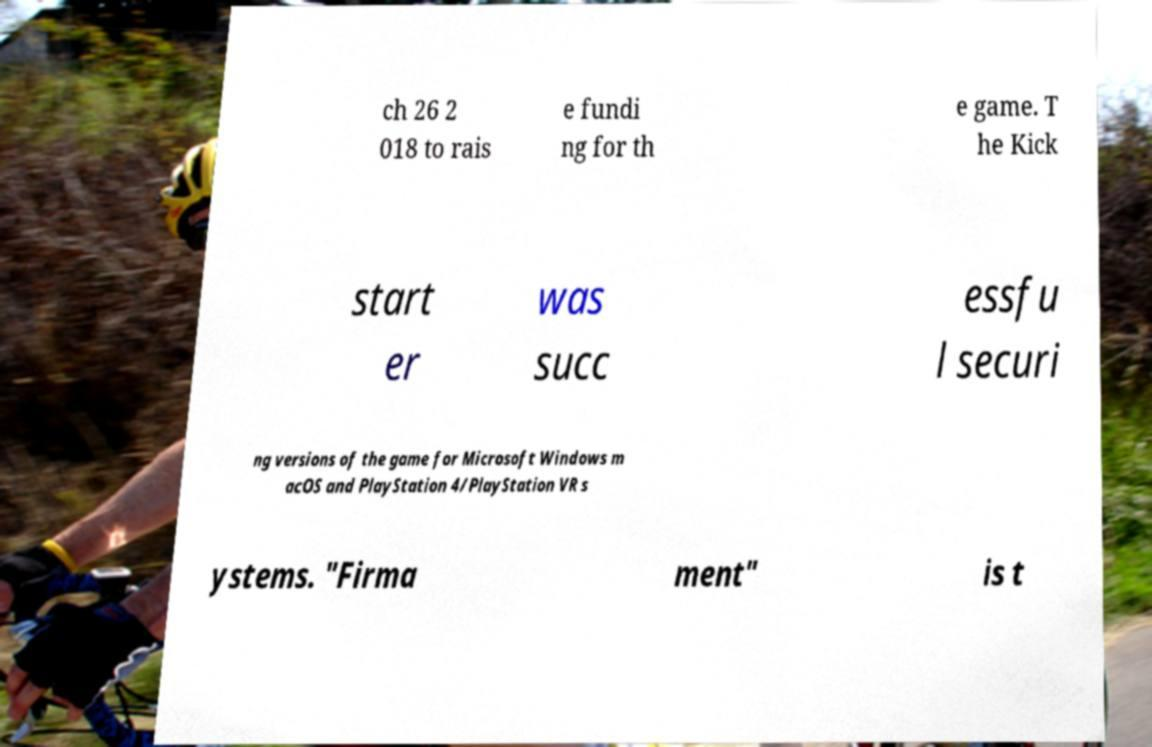For documentation purposes, I need the text within this image transcribed. Could you provide that? ch 26 2 018 to rais e fundi ng for th e game. T he Kick start er was succ essfu l securi ng versions of the game for Microsoft Windows m acOS and PlayStation 4/PlayStation VR s ystems. "Firma ment" is t 